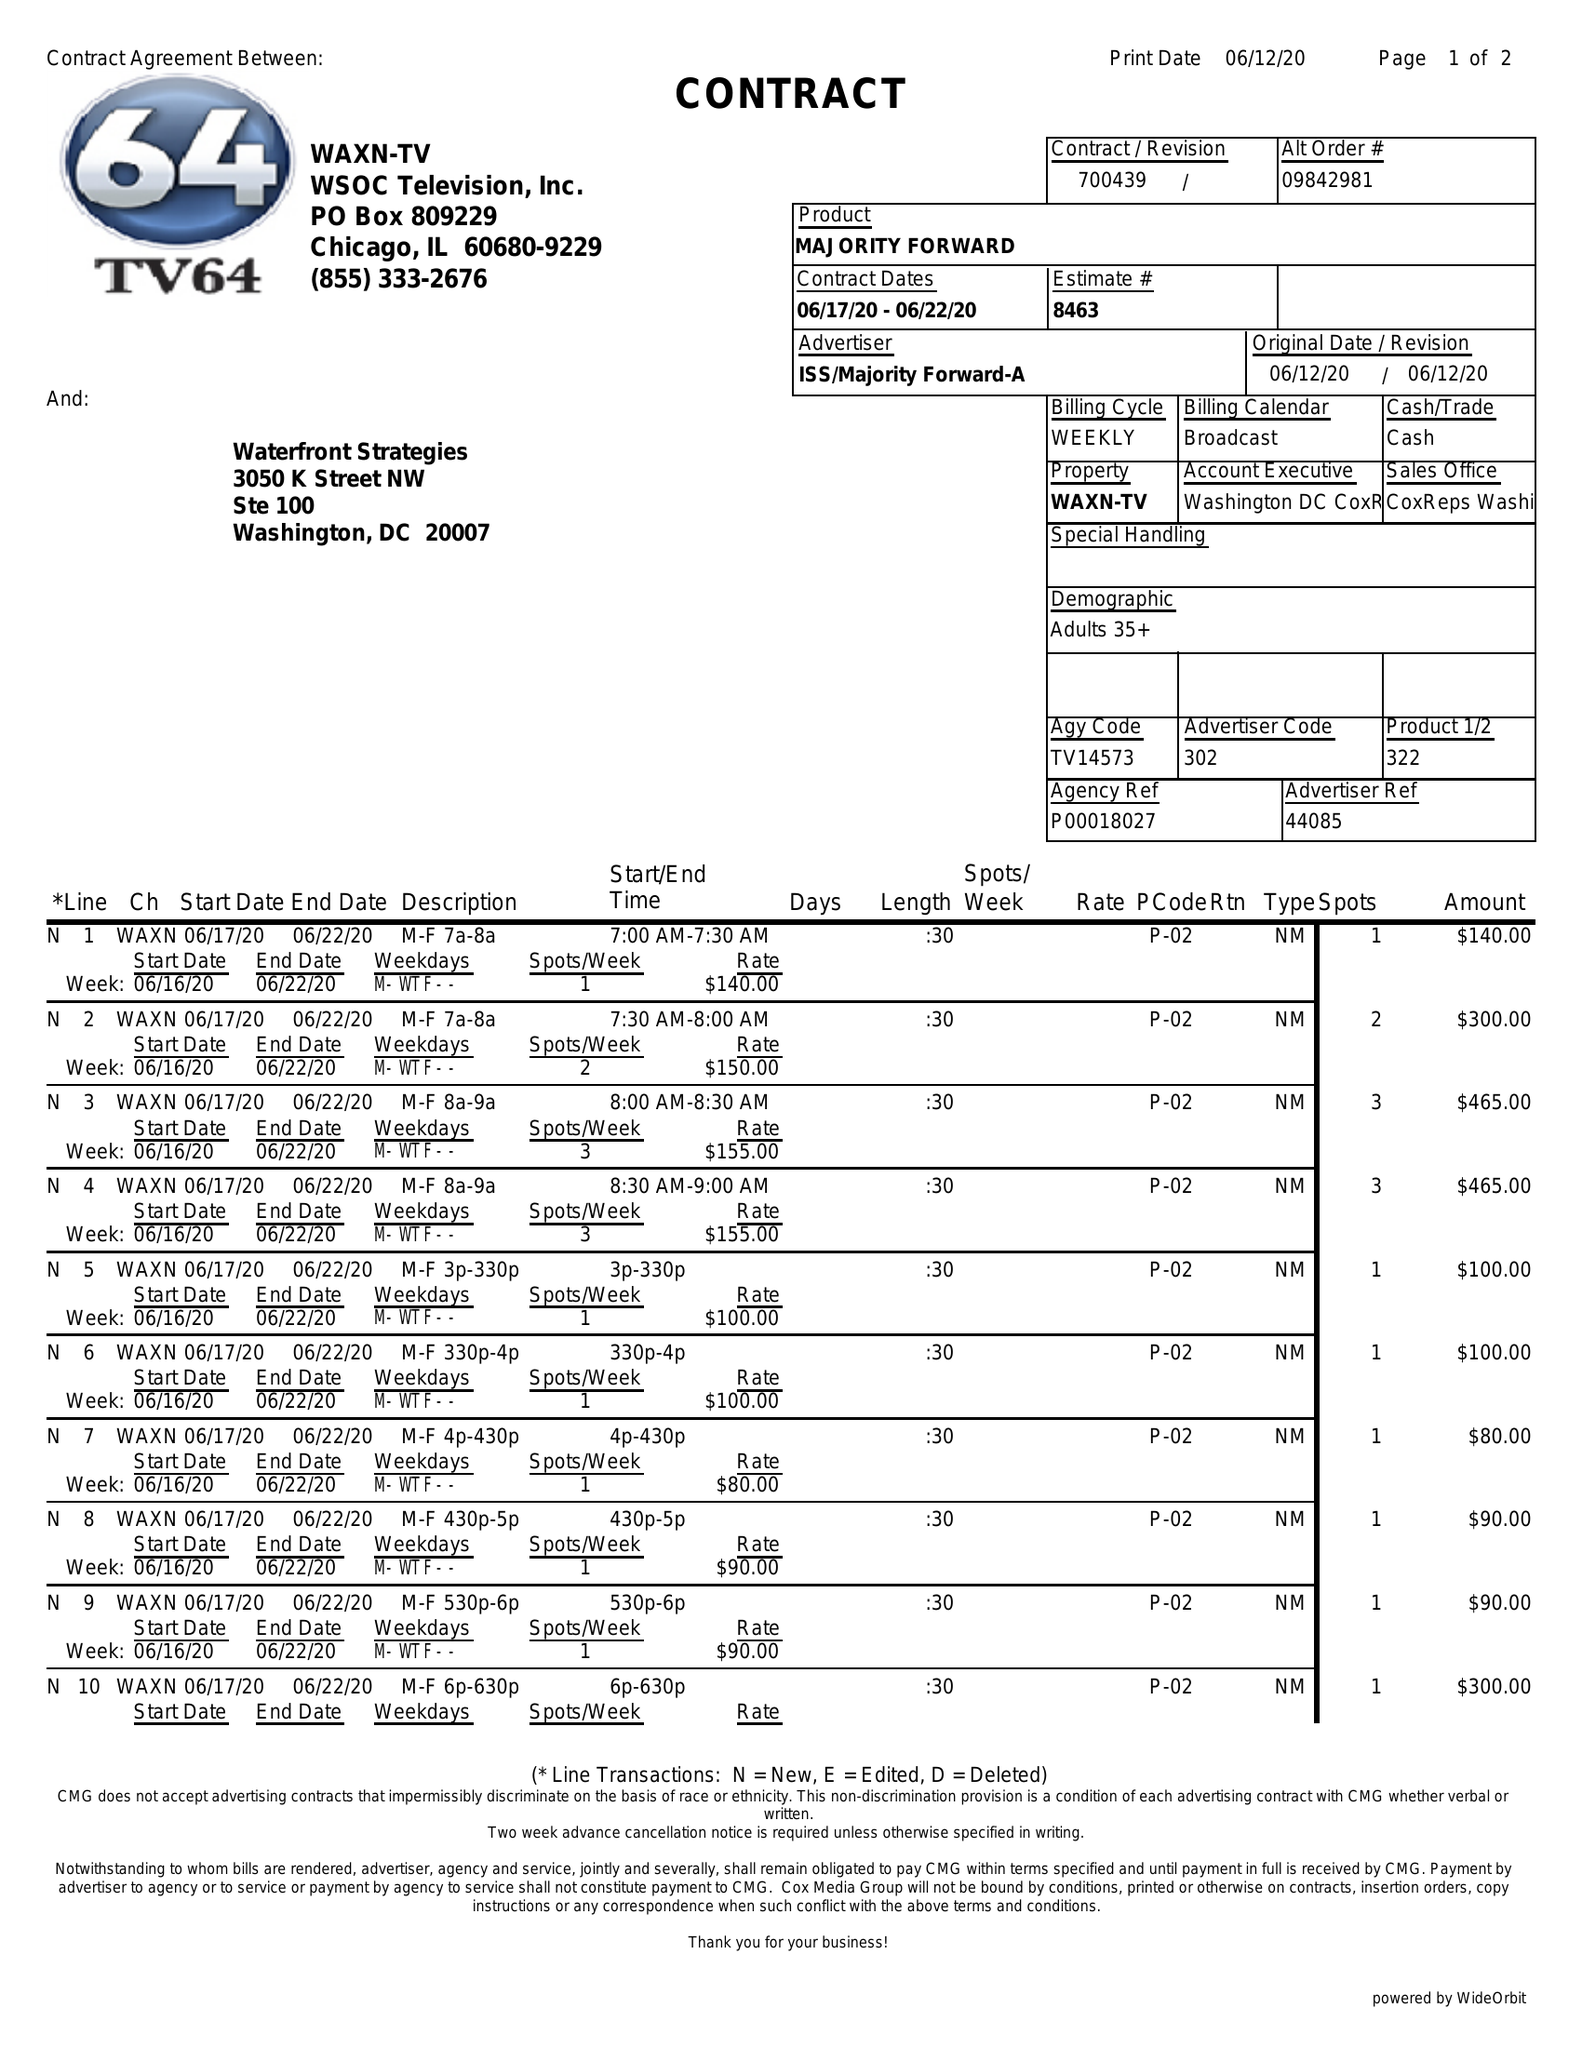What is the value for the flight_from?
Answer the question using a single word or phrase. 06/17/20 